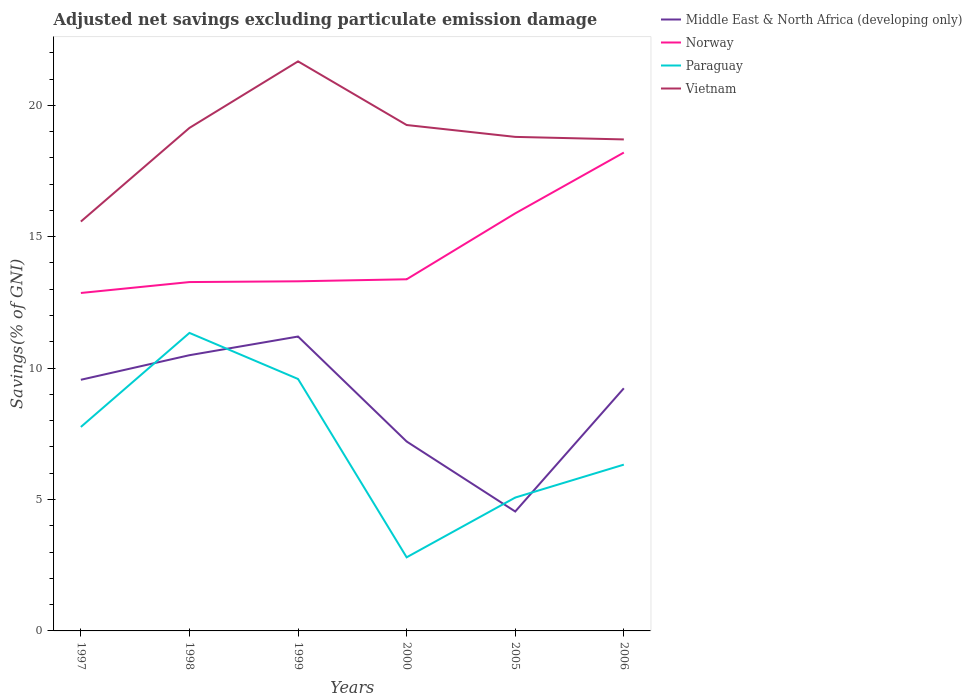Is the number of lines equal to the number of legend labels?
Keep it short and to the point. Yes. Across all years, what is the maximum adjusted net savings in Paraguay?
Provide a short and direct response. 2.8. In which year was the adjusted net savings in Middle East & North Africa (developing only) maximum?
Your answer should be compact. 2005. What is the total adjusted net savings in Norway in the graph?
Make the answer very short. -2.61. What is the difference between the highest and the second highest adjusted net savings in Vietnam?
Your answer should be compact. 6.09. Is the adjusted net savings in Paraguay strictly greater than the adjusted net savings in Middle East & North Africa (developing only) over the years?
Make the answer very short. No. How many lines are there?
Provide a succinct answer. 4. How many years are there in the graph?
Offer a terse response. 6. Are the values on the major ticks of Y-axis written in scientific E-notation?
Offer a very short reply. No. Does the graph contain any zero values?
Your response must be concise. No. Does the graph contain grids?
Provide a succinct answer. No. Where does the legend appear in the graph?
Make the answer very short. Top right. What is the title of the graph?
Ensure brevity in your answer.  Adjusted net savings excluding particulate emission damage. What is the label or title of the X-axis?
Give a very brief answer. Years. What is the label or title of the Y-axis?
Give a very brief answer. Savings(% of GNI). What is the Savings(% of GNI) of Middle East & North Africa (developing only) in 1997?
Make the answer very short. 9.56. What is the Savings(% of GNI) of Norway in 1997?
Provide a succinct answer. 12.86. What is the Savings(% of GNI) of Paraguay in 1997?
Your answer should be compact. 7.76. What is the Savings(% of GNI) of Vietnam in 1997?
Offer a terse response. 15.58. What is the Savings(% of GNI) in Middle East & North Africa (developing only) in 1998?
Ensure brevity in your answer.  10.49. What is the Savings(% of GNI) of Norway in 1998?
Provide a short and direct response. 13.27. What is the Savings(% of GNI) of Paraguay in 1998?
Keep it short and to the point. 11.34. What is the Savings(% of GNI) in Vietnam in 1998?
Your answer should be compact. 19.14. What is the Savings(% of GNI) of Middle East & North Africa (developing only) in 1999?
Offer a very short reply. 11.2. What is the Savings(% of GNI) of Norway in 1999?
Provide a succinct answer. 13.3. What is the Savings(% of GNI) of Paraguay in 1999?
Your answer should be very brief. 9.59. What is the Savings(% of GNI) of Vietnam in 1999?
Your response must be concise. 21.67. What is the Savings(% of GNI) in Middle East & North Africa (developing only) in 2000?
Offer a terse response. 7.21. What is the Savings(% of GNI) in Norway in 2000?
Offer a very short reply. 13.38. What is the Savings(% of GNI) of Paraguay in 2000?
Offer a terse response. 2.8. What is the Savings(% of GNI) of Vietnam in 2000?
Give a very brief answer. 19.25. What is the Savings(% of GNI) of Middle East & North Africa (developing only) in 2005?
Provide a succinct answer. 4.54. What is the Savings(% of GNI) of Norway in 2005?
Provide a succinct answer. 15.89. What is the Savings(% of GNI) in Paraguay in 2005?
Offer a very short reply. 5.07. What is the Savings(% of GNI) of Vietnam in 2005?
Ensure brevity in your answer.  18.8. What is the Savings(% of GNI) of Middle East & North Africa (developing only) in 2006?
Offer a very short reply. 9.23. What is the Savings(% of GNI) of Norway in 2006?
Provide a succinct answer. 18.2. What is the Savings(% of GNI) of Paraguay in 2006?
Offer a terse response. 6.33. What is the Savings(% of GNI) in Vietnam in 2006?
Provide a short and direct response. 18.7. Across all years, what is the maximum Savings(% of GNI) in Middle East & North Africa (developing only)?
Offer a very short reply. 11.2. Across all years, what is the maximum Savings(% of GNI) in Norway?
Make the answer very short. 18.2. Across all years, what is the maximum Savings(% of GNI) in Paraguay?
Offer a very short reply. 11.34. Across all years, what is the maximum Savings(% of GNI) in Vietnam?
Your response must be concise. 21.67. Across all years, what is the minimum Savings(% of GNI) of Middle East & North Africa (developing only)?
Your answer should be compact. 4.54. Across all years, what is the minimum Savings(% of GNI) in Norway?
Your response must be concise. 12.86. Across all years, what is the minimum Savings(% of GNI) in Paraguay?
Ensure brevity in your answer.  2.8. Across all years, what is the minimum Savings(% of GNI) of Vietnam?
Provide a short and direct response. 15.58. What is the total Savings(% of GNI) in Middle East & North Africa (developing only) in the graph?
Ensure brevity in your answer.  52.23. What is the total Savings(% of GNI) of Norway in the graph?
Provide a succinct answer. 86.9. What is the total Savings(% of GNI) in Paraguay in the graph?
Offer a terse response. 42.89. What is the total Savings(% of GNI) in Vietnam in the graph?
Provide a short and direct response. 113.13. What is the difference between the Savings(% of GNI) of Middle East & North Africa (developing only) in 1997 and that in 1998?
Your response must be concise. -0.93. What is the difference between the Savings(% of GNI) of Norway in 1997 and that in 1998?
Provide a succinct answer. -0.42. What is the difference between the Savings(% of GNI) in Paraguay in 1997 and that in 1998?
Provide a succinct answer. -3.58. What is the difference between the Savings(% of GNI) in Vietnam in 1997 and that in 1998?
Keep it short and to the point. -3.56. What is the difference between the Savings(% of GNI) in Middle East & North Africa (developing only) in 1997 and that in 1999?
Offer a very short reply. -1.65. What is the difference between the Savings(% of GNI) of Norway in 1997 and that in 1999?
Offer a terse response. -0.44. What is the difference between the Savings(% of GNI) of Paraguay in 1997 and that in 1999?
Your answer should be very brief. -1.83. What is the difference between the Savings(% of GNI) of Vietnam in 1997 and that in 1999?
Offer a terse response. -6.09. What is the difference between the Savings(% of GNI) in Middle East & North Africa (developing only) in 1997 and that in 2000?
Your answer should be very brief. 2.35. What is the difference between the Savings(% of GNI) of Norway in 1997 and that in 2000?
Your answer should be compact. -0.52. What is the difference between the Savings(% of GNI) in Paraguay in 1997 and that in 2000?
Give a very brief answer. 4.96. What is the difference between the Savings(% of GNI) in Vietnam in 1997 and that in 2000?
Offer a terse response. -3.67. What is the difference between the Savings(% of GNI) in Middle East & North Africa (developing only) in 1997 and that in 2005?
Offer a very short reply. 5.01. What is the difference between the Savings(% of GNI) of Norway in 1997 and that in 2005?
Make the answer very short. -3.03. What is the difference between the Savings(% of GNI) in Paraguay in 1997 and that in 2005?
Make the answer very short. 2.69. What is the difference between the Savings(% of GNI) of Vietnam in 1997 and that in 2005?
Your answer should be compact. -3.22. What is the difference between the Savings(% of GNI) of Middle East & North Africa (developing only) in 1997 and that in 2006?
Your response must be concise. 0.32. What is the difference between the Savings(% of GNI) of Norway in 1997 and that in 2006?
Your answer should be very brief. -5.34. What is the difference between the Savings(% of GNI) of Paraguay in 1997 and that in 2006?
Offer a terse response. 1.43. What is the difference between the Savings(% of GNI) in Vietnam in 1997 and that in 2006?
Your answer should be very brief. -3.12. What is the difference between the Savings(% of GNI) of Middle East & North Africa (developing only) in 1998 and that in 1999?
Ensure brevity in your answer.  -0.71. What is the difference between the Savings(% of GNI) in Norway in 1998 and that in 1999?
Keep it short and to the point. -0.03. What is the difference between the Savings(% of GNI) of Paraguay in 1998 and that in 1999?
Ensure brevity in your answer.  1.75. What is the difference between the Savings(% of GNI) of Vietnam in 1998 and that in 1999?
Provide a succinct answer. -2.53. What is the difference between the Savings(% of GNI) of Middle East & North Africa (developing only) in 1998 and that in 2000?
Your answer should be compact. 3.28. What is the difference between the Savings(% of GNI) in Norway in 1998 and that in 2000?
Make the answer very short. -0.11. What is the difference between the Savings(% of GNI) in Paraguay in 1998 and that in 2000?
Provide a short and direct response. 8.54. What is the difference between the Savings(% of GNI) in Vietnam in 1998 and that in 2000?
Offer a very short reply. -0.11. What is the difference between the Savings(% of GNI) of Middle East & North Africa (developing only) in 1998 and that in 2005?
Give a very brief answer. 5.95. What is the difference between the Savings(% of GNI) in Norway in 1998 and that in 2005?
Offer a terse response. -2.61. What is the difference between the Savings(% of GNI) of Paraguay in 1998 and that in 2005?
Your answer should be very brief. 6.26. What is the difference between the Savings(% of GNI) in Vietnam in 1998 and that in 2005?
Your answer should be very brief. 0.34. What is the difference between the Savings(% of GNI) of Middle East & North Africa (developing only) in 1998 and that in 2006?
Give a very brief answer. 1.26. What is the difference between the Savings(% of GNI) in Norway in 1998 and that in 2006?
Offer a terse response. -4.93. What is the difference between the Savings(% of GNI) of Paraguay in 1998 and that in 2006?
Your answer should be compact. 5.01. What is the difference between the Savings(% of GNI) in Vietnam in 1998 and that in 2006?
Your response must be concise. 0.44. What is the difference between the Savings(% of GNI) in Middle East & North Africa (developing only) in 1999 and that in 2000?
Your answer should be compact. 3.99. What is the difference between the Savings(% of GNI) of Norway in 1999 and that in 2000?
Provide a short and direct response. -0.08. What is the difference between the Savings(% of GNI) of Paraguay in 1999 and that in 2000?
Offer a very short reply. 6.79. What is the difference between the Savings(% of GNI) of Vietnam in 1999 and that in 2000?
Offer a very short reply. 2.42. What is the difference between the Savings(% of GNI) of Middle East & North Africa (developing only) in 1999 and that in 2005?
Make the answer very short. 6.66. What is the difference between the Savings(% of GNI) of Norway in 1999 and that in 2005?
Provide a succinct answer. -2.58. What is the difference between the Savings(% of GNI) in Paraguay in 1999 and that in 2005?
Your answer should be compact. 4.51. What is the difference between the Savings(% of GNI) in Vietnam in 1999 and that in 2005?
Give a very brief answer. 2.87. What is the difference between the Savings(% of GNI) in Middle East & North Africa (developing only) in 1999 and that in 2006?
Your response must be concise. 1.97. What is the difference between the Savings(% of GNI) of Norway in 1999 and that in 2006?
Your response must be concise. -4.9. What is the difference between the Savings(% of GNI) in Paraguay in 1999 and that in 2006?
Give a very brief answer. 3.26. What is the difference between the Savings(% of GNI) of Vietnam in 1999 and that in 2006?
Your answer should be compact. 2.97. What is the difference between the Savings(% of GNI) of Middle East & North Africa (developing only) in 2000 and that in 2005?
Your answer should be compact. 2.66. What is the difference between the Savings(% of GNI) of Norway in 2000 and that in 2005?
Provide a succinct answer. -2.51. What is the difference between the Savings(% of GNI) of Paraguay in 2000 and that in 2005?
Your response must be concise. -2.27. What is the difference between the Savings(% of GNI) of Vietnam in 2000 and that in 2005?
Your response must be concise. 0.45. What is the difference between the Savings(% of GNI) of Middle East & North Africa (developing only) in 2000 and that in 2006?
Make the answer very short. -2.02. What is the difference between the Savings(% of GNI) of Norway in 2000 and that in 2006?
Provide a succinct answer. -4.82. What is the difference between the Savings(% of GNI) in Paraguay in 2000 and that in 2006?
Make the answer very short. -3.53. What is the difference between the Savings(% of GNI) of Vietnam in 2000 and that in 2006?
Provide a short and direct response. 0.55. What is the difference between the Savings(% of GNI) of Middle East & North Africa (developing only) in 2005 and that in 2006?
Provide a succinct answer. -4.69. What is the difference between the Savings(% of GNI) of Norway in 2005 and that in 2006?
Keep it short and to the point. -2.31. What is the difference between the Savings(% of GNI) in Paraguay in 2005 and that in 2006?
Offer a terse response. -1.25. What is the difference between the Savings(% of GNI) in Vietnam in 2005 and that in 2006?
Your answer should be compact. 0.1. What is the difference between the Savings(% of GNI) of Middle East & North Africa (developing only) in 1997 and the Savings(% of GNI) of Norway in 1998?
Keep it short and to the point. -3.72. What is the difference between the Savings(% of GNI) in Middle East & North Africa (developing only) in 1997 and the Savings(% of GNI) in Paraguay in 1998?
Make the answer very short. -1.78. What is the difference between the Savings(% of GNI) of Middle East & North Africa (developing only) in 1997 and the Savings(% of GNI) of Vietnam in 1998?
Keep it short and to the point. -9.58. What is the difference between the Savings(% of GNI) in Norway in 1997 and the Savings(% of GNI) in Paraguay in 1998?
Provide a succinct answer. 1.52. What is the difference between the Savings(% of GNI) of Norway in 1997 and the Savings(% of GNI) of Vietnam in 1998?
Your answer should be compact. -6.28. What is the difference between the Savings(% of GNI) of Paraguay in 1997 and the Savings(% of GNI) of Vietnam in 1998?
Keep it short and to the point. -11.38. What is the difference between the Savings(% of GNI) of Middle East & North Africa (developing only) in 1997 and the Savings(% of GNI) of Norway in 1999?
Your answer should be very brief. -3.75. What is the difference between the Savings(% of GNI) in Middle East & North Africa (developing only) in 1997 and the Savings(% of GNI) in Paraguay in 1999?
Provide a succinct answer. -0.03. What is the difference between the Savings(% of GNI) in Middle East & North Africa (developing only) in 1997 and the Savings(% of GNI) in Vietnam in 1999?
Provide a succinct answer. -12.11. What is the difference between the Savings(% of GNI) in Norway in 1997 and the Savings(% of GNI) in Paraguay in 1999?
Your answer should be compact. 3.27. What is the difference between the Savings(% of GNI) of Norway in 1997 and the Savings(% of GNI) of Vietnam in 1999?
Keep it short and to the point. -8.81. What is the difference between the Savings(% of GNI) of Paraguay in 1997 and the Savings(% of GNI) of Vietnam in 1999?
Your answer should be very brief. -13.91. What is the difference between the Savings(% of GNI) in Middle East & North Africa (developing only) in 1997 and the Savings(% of GNI) in Norway in 2000?
Your answer should be compact. -3.82. What is the difference between the Savings(% of GNI) of Middle East & North Africa (developing only) in 1997 and the Savings(% of GNI) of Paraguay in 2000?
Your answer should be compact. 6.76. What is the difference between the Savings(% of GNI) in Middle East & North Africa (developing only) in 1997 and the Savings(% of GNI) in Vietnam in 2000?
Your answer should be very brief. -9.69. What is the difference between the Savings(% of GNI) of Norway in 1997 and the Savings(% of GNI) of Paraguay in 2000?
Your response must be concise. 10.06. What is the difference between the Savings(% of GNI) of Norway in 1997 and the Savings(% of GNI) of Vietnam in 2000?
Offer a very short reply. -6.39. What is the difference between the Savings(% of GNI) in Paraguay in 1997 and the Savings(% of GNI) in Vietnam in 2000?
Your answer should be compact. -11.49. What is the difference between the Savings(% of GNI) of Middle East & North Africa (developing only) in 1997 and the Savings(% of GNI) of Norway in 2005?
Give a very brief answer. -6.33. What is the difference between the Savings(% of GNI) in Middle East & North Africa (developing only) in 1997 and the Savings(% of GNI) in Paraguay in 2005?
Your answer should be compact. 4.48. What is the difference between the Savings(% of GNI) of Middle East & North Africa (developing only) in 1997 and the Savings(% of GNI) of Vietnam in 2005?
Provide a succinct answer. -9.24. What is the difference between the Savings(% of GNI) of Norway in 1997 and the Savings(% of GNI) of Paraguay in 2005?
Ensure brevity in your answer.  7.78. What is the difference between the Savings(% of GNI) of Norway in 1997 and the Savings(% of GNI) of Vietnam in 2005?
Provide a succinct answer. -5.94. What is the difference between the Savings(% of GNI) in Paraguay in 1997 and the Savings(% of GNI) in Vietnam in 2005?
Your answer should be compact. -11.04. What is the difference between the Savings(% of GNI) of Middle East & North Africa (developing only) in 1997 and the Savings(% of GNI) of Norway in 2006?
Keep it short and to the point. -8.65. What is the difference between the Savings(% of GNI) in Middle East & North Africa (developing only) in 1997 and the Savings(% of GNI) in Paraguay in 2006?
Provide a succinct answer. 3.23. What is the difference between the Savings(% of GNI) in Middle East & North Africa (developing only) in 1997 and the Savings(% of GNI) in Vietnam in 2006?
Your answer should be very brief. -9.14. What is the difference between the Savings(% of GNI) in Norway in 1997 and the Savings(% of GNI) in Paraguay in 2006?
Your answer should be compact. 6.53. What is the difference between the Savings(% of GNI) of Norway in 1997 and the Savings(% of GNI) of Vietnam in 2006?
Give a very brief answer. -5.84. What is the difference between the Savings(% of GNI) of Paraguay in 1997 and the Savings(% of GNI) of Vietnam in 2006?
Your answer should be compact. -10.94. What is the difference between the Savings(% of GNI) of Middle East & North Africa (developing only) in 1998 and the Savings(% of GNI) of Norway in 1999?
Make the answer very short. -2.81. What is the difference between the Savings(% of GNI) of Middle East & North Africa (developing only) in 1998 and the Savings(% of GNI) of Paraguay in 1999?
Your answer should be very brief. 0.91. What is the difference between the Savings(% of GNI) of Middle East & North Africa (developing only) in 1998 and the Savings(% of GNI) of Vietnam in 1999?
Your answer should be very brief. -11.18. What is the difference between the Savings(% of GNI) of Norway in 1998 and the Savings(% of GNI) of Paraguay in 1999?
Your answer should be compact. 3.69. What is the difference between the Savings(% of GNI) in Norway in 1998 and the Savings(% of GNI) in Vietnam in 1999?
Make the answer very short. -8.4. What is the difference between the Savings(% of GNI) in Paraguay in 1998 and the Savings(% of GNI) in Vietnam in 1999?
Your response must be concise. -10.33. What is the difference between the Savings(% of GNI) in Middle East & North Africa (developing only) in 1998 and the Savings(% of GNI) in Norway in 2000?
Provide a succinct answer. -2.89. What is the difference between the Savings(% of GNI) of Middle East & North Africa (developing only) in 1998 and the Savings(% of GNI) of Paraguay in 2000?
Ensure brevity in your answer.  7.69. What is the difference between the Savings(% of GNI) of Middle East & North Africa (developing only) in 1998 and the Savings(% of GNI) of Vietnam in 2000?
Keep it short and to the point. -8.76. What is the difference between the Savings(% of GNI) of Norway in 1998 and the Savings(% of GNI) of Paraguay in 2000?
Your response must be concise. 10.47. What is the difference between the Savings(% of GNI) of Norway in 1998 and the Savings(% of GNI) of Vietnam in 2000?
Provide a succinct answer. -5.98. What is the difference between the Savings(% of GNI) in Paraguay in 1998 and the Savings(% of GNI) in Vietnam in 2000?
Offer a very short reply. -7.91. What is the difference between the Savings(% of GNI) in Middle East & North Africa (developing only) in 1998 and the Savings(% of GNI) in Norway in 2005?
Keep it short and to the point. -5.4. What is the difference between the Savings(% of GNI) of Middle East & North Africa (developing only) in 1998 and the Savings(% of GNI) of Paraguay in 2005?
Your answer should be very brief. 5.42. What is the difference between the Savings(% of GNI) in Middle East & North Africa (developing only) in 1998 and the Savings(% of GNI) in Vietnam in 2005?
Your answer should be very brief. -8.31. What is the difference between the Savings(% of GNI) of Norway in 1998 and the Savings(% of GNI) of Paraguay in 2005?
Provide a succinct answer. 8.2. What is the difference between the Savings(% of GNI) of Norway in 1998 and the Savings(% of GNI) of Vietnam in 2005?
Ensure brevity in your answer.  -5.52. What is the difference between the Savings(% of GNI) of Paraguay in 1998 and the Savings(% of GNI) of Vietnam in 2005?
Keep it short and to the point. -7.46. What is the difference between the Savings(% of GNI) of Middle East & North Africa (developing only) in 1998 and the Savings(% of GNI) of Norway in 2006?
Offer a terse response. -7.71. What is the difference between the Savings(% of GNI) in Middle East & North Africa (developing only) in 1998 and the Savings(% of GNI) in Paraguay in 2006?
Your answer should be very brief. 4.16. What is the difference between the Savings(% of GNI) in Middle East & North Africa (developing only) in 1998 and the Savings(% of GNI) in Vietnam in 2006?
Ensure brevity in your answer.  -8.21. What is the difference between the Savings(% of GNI) in Norway in 1998 and the Savings(% of GNI) in Paraguay in 2006?
Ensure brevity in your answer.  6.95. What is the difference between the Savings(% of GNI) of Norway in 1998 and the Savings(% of GNI) of Vietnam in 2006?
Your answer should be very brief. -5.43. What is the difference between the Savings(% of GNI) of Paraguay in 1998 and the Savings(% of GNI) of Vietnam in 2006?
Your answer should be very brief. -7.36. What is the difference between the Savings(% of GNI) in Middle East & North Africa (developing only) in 1999 and the Savings(% of GNI) in Norway in 2000?
Your answer should be very brief. -2.18. What is the difference between the Savings(% of GNI) in Middle East & North Africa (developing only) in 1999 and the Savings(% of GNI) in Paraguay in 2000?
Give a very brief answer. 8.4. What is the difference between the Savings(% of GNI) in Middle East & North Africa (developing only) in 1999 and the Savings(% of GNI) in Vietnam in 2000?
Your response must be concise. -8.05. What is the difference between the Savings(% of GNI) of Norway in 1999 and the Savings(% of GNI) of Paraguay in 2000?
Give a very brief answer. 10.5. What is the difference between the Savings(% of GNI) in Norway in 1999 and the Savings(% of GNI) in Vietnam in 2000?
Keep it short and to the point. -5.95. What is the difference between the Savings(% of GNI) of Paraguay in 1999 and the Savings(% of GNI) of Vietnam in 2000?
Ensure brevity in your answer.  -9.66. What is the difference between the Savings(% of GNI) of Middle East & North Africa (developing only) in 1999 and the Savings(% of GNI) of Norway in 2005?
Ensure brevity in your answer.  -4.69. What is the difference between the Savings(% of GNI) of Middle East & North Africa (developing only) in 1999 and the Savings(% of GNI) of Paraguay in 2005?
Provide a short and direct response. 6.13. What is the difference between the Savings(% of GNI) in Middle East & North Africa (developing only) in 1999 and the Savings(% of GNI) in Vietnam in 2005?
Offer a terse response. -7.6. What is the difference between the Savings(% of GNI) in Norway in 1999 and the Savings(% of GNI) in Paraguay in 2005?
Your answer should be very brief. 8.23. What is the difference between the Savings(% of GNI) in Norway in 1999 and the Savings(% of GNI) in Vietnam in 2005?
Keep it short and to the point. -5.49. What is the difference between the Savings(% of GNI) of Paraguay in 1999 and the Savings(% of GNI) of Vietnam in 2005?
Your response must be concise. -9.21. What is the difference between the Savings(% of GNI) in Middle East & North Africa (developing only) in 1999 and the Savings(% of GNI) in Norway in 2006?
Your answer should be compact. -7. What is the difference between the Savings(% of GNI) in Middle East & North Africa (developing only) in 1999 and the Savings(% of GNI) in Paraguay in 2006?
Your answer should be compact. 4.87. What is the difference between the Savings(% of GNI) in Middle East & North Africa (developing only) in 1999 and the Savings(% of GNI) in Vietnam in 2006?
Offer a terse response. -7.5. What is the difference between the Savings(% of GNI) of Norway in 1999 and the Savings(% of GNI) of Paraguay in 2006?
Keep it short and to the point. 6.98. What is the difference between the Savings(% of GNI) in Norway in 1999 and the Savings(% of GNI) in Vietnam in 2006?
Keep it short and to the point. -5.4. What is the difference between the Savings(% of GNI) of Paraguay in 1999 and the Savings(% of GNI) of Vietnam in 2006?
Give a very brief answer. -9.12. What is the difference between the Savings(% of GNI) in Middle East & North Africa (developing only) in 2000 and the Savings(% of GNI) in Norway in 2005?
Provide a succinct answer. -8.68. What is the difference between the Savings(% of GNI) in Middle East & North Africa (developing only) in 2000 and the Savings(% of GNI) in Paraguay in 2005?
Provide a short and direct response. 2.13. What is the difference between the Savings(% of GNI) of Middle East & North Africa (developing only) in 2000 and the Savings(% of GNI) of Vietnam in 2005?
Offer a terse response. -11.59. What is the difference between the Savings(% of GNI) in Norway in 2000 and the Savings(% of GNI) in Paraguay in 2005?
Make the answer very short. 8.3. What is the difference between the Savings(% of GNI) in Norway in 2000 and the Savings(% of GNI) in Vietnam in 2005?
Your answer should be compact. -5.42. What is the difference between the Savings(% of GNI) in Paraguay in 2000 and the Savings(% of GNI) in Vietnam in 2005?
Your answer should be very brief. -16. What is the difference between the Savings(% of GNI) of Middle East & North Africa (developing only) in 2000 and the Savings(% of GNI) of Norway in 2006?
Keep it short and to the point. -10.99. What is the difference between the Savings(% of GNI) of Middle East & North Africa (developing only) in 2000 and the Savings(% of GNI) of Paraguay in 2006?
Provide a short and direct response. 0.88. What is the difference between the Savings(% of GNI) of Middle East & North Africa (developing only) in 2000 and the Savings(% of GNI) of Vietnam in 2006?
Give a very brief answer. -11.49. What is the difference between the Savings(% of GNI) in Norway in 2000 and the Savings(% of GNI) in Paraguay in 2006?
Your response must be concise. 7.05. What is the difference between the Savings(% of GNI) of Norway in 2000 and the Savings(% of GNI) of Vietnam in 2006?
Provide a succinct answer. -5.32. What is the difference between the Savings(% of GNI) in Paraguay in 2000 and the Savings(% of GNI) in Vietnam in 2006?
Provide a short and direct response. -15.9. What is the difference between the Savings(% of GNI) of Middle East & North Africa (developing only) in 2005 and the Savings(% of GNI) of Norway in 2006?
Give a very brief answer. -13.66. What is the difference between the Savings(% of GNI) of Middle East & North Africa (developing only) in 2005 and the Savings(% of GNI) of Paraguay in 2006?
Ensure brevity in your answer.  -1.78. What is the difference between the Savings(% of GNI) of Middle East & North Africa (developing only) in 2005 and the Savings(% of GNI) of Vietnam in 2006?
Your answer should be compact. -14.16. What is the difference between the Savings(% of GNI) of Norway in 2005 and the Savings(% of GNI) of Paraguay in 2006?
Provide a succinct answer. 9.56. What is the difference between the Savings(% of GNI) of Norway in 2005 and the Savings(% of GNI) of Vietnam in 2006?
Your answer should be very brief. -2.81. What is the difference between the Savings(% of GNI) in Paraguay in 2005 and the Savings(% of GNI) in Vietnam in 2006?
Your response must be concise. -13.63. What is the average Savings(% of GNI) in Middle East & North Africa (developing only) per year?
Give a very brief answer. 8.71. What is the average Savings(% of GNI) of Norway per year?
Keep it short and to the point. 14.48. What is the average Savings(% of GNI) in Paraguay per year?
Your answer should be very brief. 7.15. What is the average Savings(% of GNI) of Vietnam per year?
Provide a succinct answer. 18.86. In the year 1997, what is the difference between the Savings(% of GNI) of Middle East & North Africa (developing only) and Savings(% of GNI) of Norway?
Your answer should be compact. -3.3. In the year 1997, what is the difference between the Savings(% of GNI) in Middle East & North Africa (developing only) and Savings(% of GNI) in Paraguay?
Provide a short and direct response. 1.8. In the year 1997, what is the difference between the Savings(% of GNI) of Middle East & North Africa (developing only) and Savings(% of GNI) of Vietnam?
Your response must be concise. -6.02. In the year 1997, what is the difference between the Savings(% of GNI) of Norway and Savings(% of GNI) of Paraguay?
Your response must be concise. 5.1. In the year 1997, what is the difference between the Savings(% of GNI) of Norway and Savings(% of GNI) of Vietnam?
Your answer should be compact. -2.72. In the year 1997, what is the difference between the Savings(% of GNI) of Paraguay and Savings(% of GNI) of Vietnam?
Keep it short and to the point. -7.82. In the year 1998, what is the difference between the Savings(% of GNI) of Middle East & North Africa (developing only) and Savings(% of GNI) of Norway?
Offer a terse response. -2.78. In the year 1998, what is the difference between the Savings(% of GNI) of Middle East & North Africa (developing only) and Savings(% of GNI) of Paraguay?
Give a very brief answer. -0.85. In the year 1998, what is the difference between the Savings(% of GNI) of Middle East & North Africa (developing only) and Savings(% of GNI) of Vietnam?
Your response must be concise. -8.65. In the year 1998, what is the difference between the Savings(% of GNI) in Norway and Savings(% of GNI) in Paraguay?
Ensure brevity in your answer.  1.93. In the year 1998, what is the difference between the Savings(% of GNI) in Norway and Savings(% of GNI) in Vietnam?
Offer a very short reply. -5.87. In the year 1998, what is the difference between the Savings(% of GNI) in Paraguay and Savings(% of GNI) in Vietnam?
Make the answer very short. -7.8. In the year 1999, what is the difference between the Savings(% of GNI) of Middle East & North Africa (developing only) and Savings(% of GNI) of Norway?
Offer a very short reply. -2.1. In the year 1999, what is the difference between the Savings(% of GNI) in Middle East & North Africa (developing only) and Savings(% of GNI) in Paraguay?
Your answer should be very brief. 1.62. In the year 1999, what is the difference between the Savings(% of GNI) in Middle East & North Africa (developing only) and Savings(% of GNI) in Vietnam?
Your answer should be very brief. -10.47. In the year 1999, what is the difference between the Savings(% of GNI) of Norway and Savings(% of GNI) of Paraguay?
Offer a terse response. 3.72. In the year 1999, what is the difference between the Savings(% of GNI) of Norway and Savings(% of GNI) of Vietnam?
Your response must be concise. -8.37. In the year 1999, what is the difference between the Savings(% of GNI) of Paraguay and Savings(% of GNI) of Vietnam?
Your answer should be very brief. -12.09. In the year 2000, what is the difference between the Savings(% of GNI) in Middle East & North Africa (developing only) and Savings(% of GNI) in Norway?
Your response must be concise. -6.17. In the year 2000, what is the difference between the Savings(% of GNI) of Middle East & North Africa (developing only) and Savings(% of GNI) of Paraguay?
Give a very brief answer. 4.41. In the year 2000, what is the difference between the Savings(% of GNI) in Middle East & North Africa (developing only) and Savings(% of GNI) in Vietnam?
Offer a very short reply. -12.04. In the year 2000, what is the difference between the Savings(% of GNI) of Norway and Savings(% of GNI) of Paraguay?
Provide a short and direct response. 10.58. In the year 2000, what is the difference between the Savings(% of GNI) in Norway and Savings(% of GNI) in Vietnam?
Make the answer very short. -5.87. In the year 2000, what is the difference between the Savings(% of GNI) in Paraguay and Savings(% of GNI) in Vietnam?
Give a very brief answer. -16.45. In the year 2005, what is the difference between the Savings(% of GNI) of Middle East & North Africa (developing only) and Savings(% of GNI) of Norway?
Provide a succinct answer. -11.34. In the year 2005, what is the difference between the Savings(% of GNI) in Middle East & North Africa (developing only) and Savings(% of GNI) in Paraguay?
Offer a very short reply. -0.53. In the year 2005, what is the difference between the Savings(% of GNI) of Middle East & North Africa (developing only) and Savings(% of GNI) of Vietnam?
Offer a very short reply. -14.25. In the year 2005, what is the difference between the Savings(% of GNI) of Norway and Savings(% of GNI) of Paraguay?
Provide a succinct answer. 10.81. In the year 2005, what is the difference between the Savings(% of GNI) in Norway and Savings(% of GNI) in Vietnam?
Offer a terse response. -2.91. In the year 2005, what is the difference between the Savings(% of GNI) of Paraguay and Savings(% of GNI) of Vietnam?
Offer a terse response. -13.72. In the year 2006, what is the difference between the Savings(% of GNI) in Middle East & North Africa (developing only) and Savings(% of GNI) in Norway?
Your answer should be very brief. -8.97. In the year 2006, what is the difference between the Savings(% of GNI) of Middle East & North Africa (developing only) and Savings(% of GNI) of Paraguay?
Offer a terse response. 2.9. In the year 2006, what is the difference between the Savings(% of GNI) in Middle East & North Africa (developing only) and Savings(% of GNI) in Vietnam?
Provide a short and direct response. -9.47. In the year 2006, what is the difference between the Savings(% of GNI) in Norway and Savings(% of GNI) in Paraguay?
Provide a short and direct response. 11.87. In the year 2006, what is the difference between the Savings(% of GNI) of Norway and Savings(% of GNI) of Vietnam?
Your response must be concise. -0.5. In the year 2006, what is the difference between the Savings(% of GNI) of Paraguay and Savings(% of GNI) of Vietnam?
Provide a succinct answer. -12.37. What is the ratio of the Savings(% of GNI) in Middle East & North Africa (developing only) in 1997 to that in 1998?
Offer a terse response. 0.91. What is the ratio of the Savings(% of GNI) of Norway in 1997 to that in 1998?
Provide a short and direct response. 0.97. What is the ratio of the Savings(% of GNI) in Paraguay in 1997 to that in 1998?
Your response must be concise. 0.68. What is the ratio of the Savings(% of GNI) of Vietnam in 1997 to that in 1998?
Your response must be concise. 0.81. What is the ratio of the Savings(% of GNI) of Middle East & North Africa (developing only) in 1997 to that in 1999?
Offer a terse response. 0.85. What is the ratio of the Savings(% of GNI) in Norway in 1997 to that in 1999?
Give a very brief answer. 0.97. What is the ratio of the Savings(% of GNI) of Paraguay in 1997 to that in 1999?
Ensure brevity in your answer.  0.81. What is the ratio of the Savings(% of GNI) of Vietnam in 1997 to that in 1999?
Keep it short and to the point. 0.72. What is the ratio of the Savings(% of GNI) of Middle East & North Africa (developing only) in 1997 to that in 2000?
Ensure brevity in your answer.  1.33. What is the ratio of the Savings(% of GNI) in Norway in 1997 to that in 2000?
Your answer should be compact. 0.96. What is the ratio of the Savings(% of GNI) in Paraguay in 1997 to that in 2000?
Your answer should be compact. 2.77. What is the ratio of the Savings(% of GNI) of Vietnam in 1997 to that in 2000?
Your response must be concise. 0.81. What is the ratio of the Savings(% of GNI) in Middle East & North Africa (developing only) in 1997 to that in 2005?
Provide a short and direct response. 2.1. What is the ratio of the Savings(% of GNI) in Norway in 1997 to that in 2005?
Provide a short and direct response. 0.81. What is the ratio of the Savings(% of GNI) in Paraguay in 1997 to that in 2005?
Provide a succinct answer. 1.53. What is the ratio of the Savings(% of GNI) in Vietnam in 1997 to that in 2005?
Ensure brevity in your answer.  0.83. What is the ratio of the Savings(% of GNI) in Middle East & North Africa (developing only) in 1997 to that in 2006?
Your response must be concise. 1.04. What is the ratio of the Savings(% of GNI) of Norway in 1997 to that in 2006?
Provide a short and direct response. 0.71. What is the ratio of the Savings(% of GNI) of Paraguay in 1997 to that in 2006?
Keep it short and to the point. 1.23. What is the ratio of the Savings(% of GNI) of Vietnam in 1997 to that in 2006?
Provide a succinct answer. 0.83. What is the ratio of the Savings(% of GNI) of Middle East & North Africa (developing only) in 1998 to that in 1999?
Provide a succinct answer. 0.94. What is the ratio of the Savings(% of GNI) in Norway in 1998 to that in 1999?
Provide a short and direct response. 1. What is the ratio of the Savings(% of GNI) in Paraguay in 1998 to that in 1999?
Offer a very short reply. 1.18. What is the ratio of the Savings(% of GNI) in Vietnam in 1998 to that in 1999?
Make the answer very short. 0.88. What is the ratio of the Savings(% of GNI) of Middle East & North Africa (developing only) in 1998 to that in 2000?
Your response must be concise. 1.46. What is the ratio of the Savings(% of GNI) of Paraguay in 1998 to that in 2000?
Make the answer very short. 4.05. What is the ratio of the Savings(% of GNI) in Vietnam in 1998 to that in 2000?
Offer a very short reply. 0.99. What is the ratio of the Savings(% of GNI) in Middle East & North Africa (developing only) in 1998 to that in 2005?
Provide a short and direct response. 2.31. What is the ratio of the Savings(% of GNI) of Norway in 1998 to that in 2005?
Provide a succinct answer. 0.84. What is the ratio of the Savings(% of GNI) of Paraguay in 1998 to that in 2005?
Offer a very short reply. 2.23. What is the ratio of the Savings(% of GNI) in Vietnam in 1998 to that in 2005?
Keep it short and to the point. 1.02. What is the ratio of the Savings(% of GNI) in Middle East & North Africa (developing only) in 1998 to that in 2006?
Keep it short and to the point. 1.14. What is the ratio of the Savings(% of GNI) in Norway in 1998 to that in 2006?
Your answer should be compact. 0.73. What is the ratio of the Savings(% of GNI) of Paraguay in 1998 to that in 2006?
Give a very brief answer. 1.79. What is the ratio of the Savings(% of GNI) in Vietnam in 1998 to that in 2006?
Your answer should be very brief. 1.02. What is the ratio of the Savings(% of GNI) in Middle East & North Africa (developing only) in 1999 to that in 2000?
Provide a short and direct response. 1.55. What is the ratio of the Savings(% of GNI) in Norway in 1999 to that in 2000?
Your response must be concise. 0.99. What is the ratio of the Savings(% of GNI) of Paraguay in 1999 to that in 2000?
Provide a short and direct response. 3.42. What is the ratio of the Savings(% of GNI) of Vietnam in 1999 to that in 2000?
Your response must be concise. 1.13. What is the ratio of the Savings(% of GNI) in Middle East & North Africa (developing only) in 1999 to that in 2005?
Provide a short and direct response. 2.47. What is the ratio of the Savings(% of GNI) of Norway in 1999 to that in 2005?
Offer a very short reply. 0.84. What is the ratio of the Savings(% of GNI) in Paraguay in 1999 to that in 2005?
Offer a very short reply. 1.89. What is the ratio of the Savings(% of GNI) of Vietnam in 1999 to that in 2005?
Make the answer very short. 1.15. What is the ratio of the Savings(% of GNI) in Middle East & North Africa (developing only) in 1999 to that in 2006?
Provide a succinct answer. 1.21. What is the ratio of the Savings(% of GNI) of Norway in 1999 to that in 2006?
Provide a succinct answer. 0.73. What is the ratio of the Savings(% of GNI) of Paraguay in 1999 to that in 2006?
Provide a short and direct response. 1.51. What is the ratio of the Savings(% of GNI) in Vietnam in 1999 to that in 2006?
Offer a terse response. 1.16. What is the ratio of the Savings(% of GNI) in Middle East & North Africa (developing only) in 2000 to that in 2005?
Your answer should be very brief. 1.59. What is the ratio of the Savings(% of GNI) in Norway in 2000 to that in 2005?
Your answer should be very brief. 0.84. What is the ratio of the Savings(% of GNI) of Paraguay in 2000 to that in 2005?
Offer a terse response. 0.55. What is the ratio of the Savings(% of GNI) in Middle East & North Africa (developing only) in 2000 to that in 2006?
Provide a succinct answer. 0.78. What is the ratio of the Savings(% of GNI) in Norway in 2000 to that in 2006?
Give a very brief answer. 0.74. What is the ratio of the Savings(% of GNI) of Paraguay in 2000 to that in 2006?
Give a very brief answer. 0.44. What is the ratio of the Savings(% of GNI) in Vietnam in 2000 to that in 2006?
Offer a very short reply. 1.03. What is the ratio of the Savings(% of GNI) in Middle East & North Africa (developing only) in 2005 to that in 2006?
Provide a short and direct response. 0.49. What is the ratio of the Savings(% of GNI) in Norway in 2005 to that in 2006?
Make the answer very short. 0.87. What is the ratio of the Savings(% of GNI) of Paraguay in 2005 to that in 2006?
Provide a succinct answer. 0.8. What is the ratio of the Savings(% of GNI) of Vietnam in 2005 to that in 2006?
Make the answer very short. 1.01. What is the difference between the highest and the second highest Savings(% of GNI) in Middle East & North Africa (developing only)?
Your answer should be compact. 0.71. What is the difference between the highest and the second highest Savings(% of GNI) of Norway?
Make the answer very short. 2.31. What is the difference between the highest and the second highest Savings(% of GNI) in Paraguay?
Your answer should be very brief. 1.75. What is the difference between the highest and the second highest Savings(% of GNI) of Vietnam?
Give a very brief answer. 2.42. What is the difference between the highest and the lowest Savings(% of GNI) of Middle East & North Africa (developing only)?
Offer a terse response. 6.66. What is the difference between the highest and the lowest Savings(% of GNI) of Norway?
Ensure brevity in your answer.  5.34. What is the difference between the highest and the lowest Savings(% of GNI) in Paraguay?
Provide a short and direct response. 8.54. What is the difference between the highest and the lowest Savings(% of GNI) in Vietnam?
Keep it short and to the point. 6.09. 